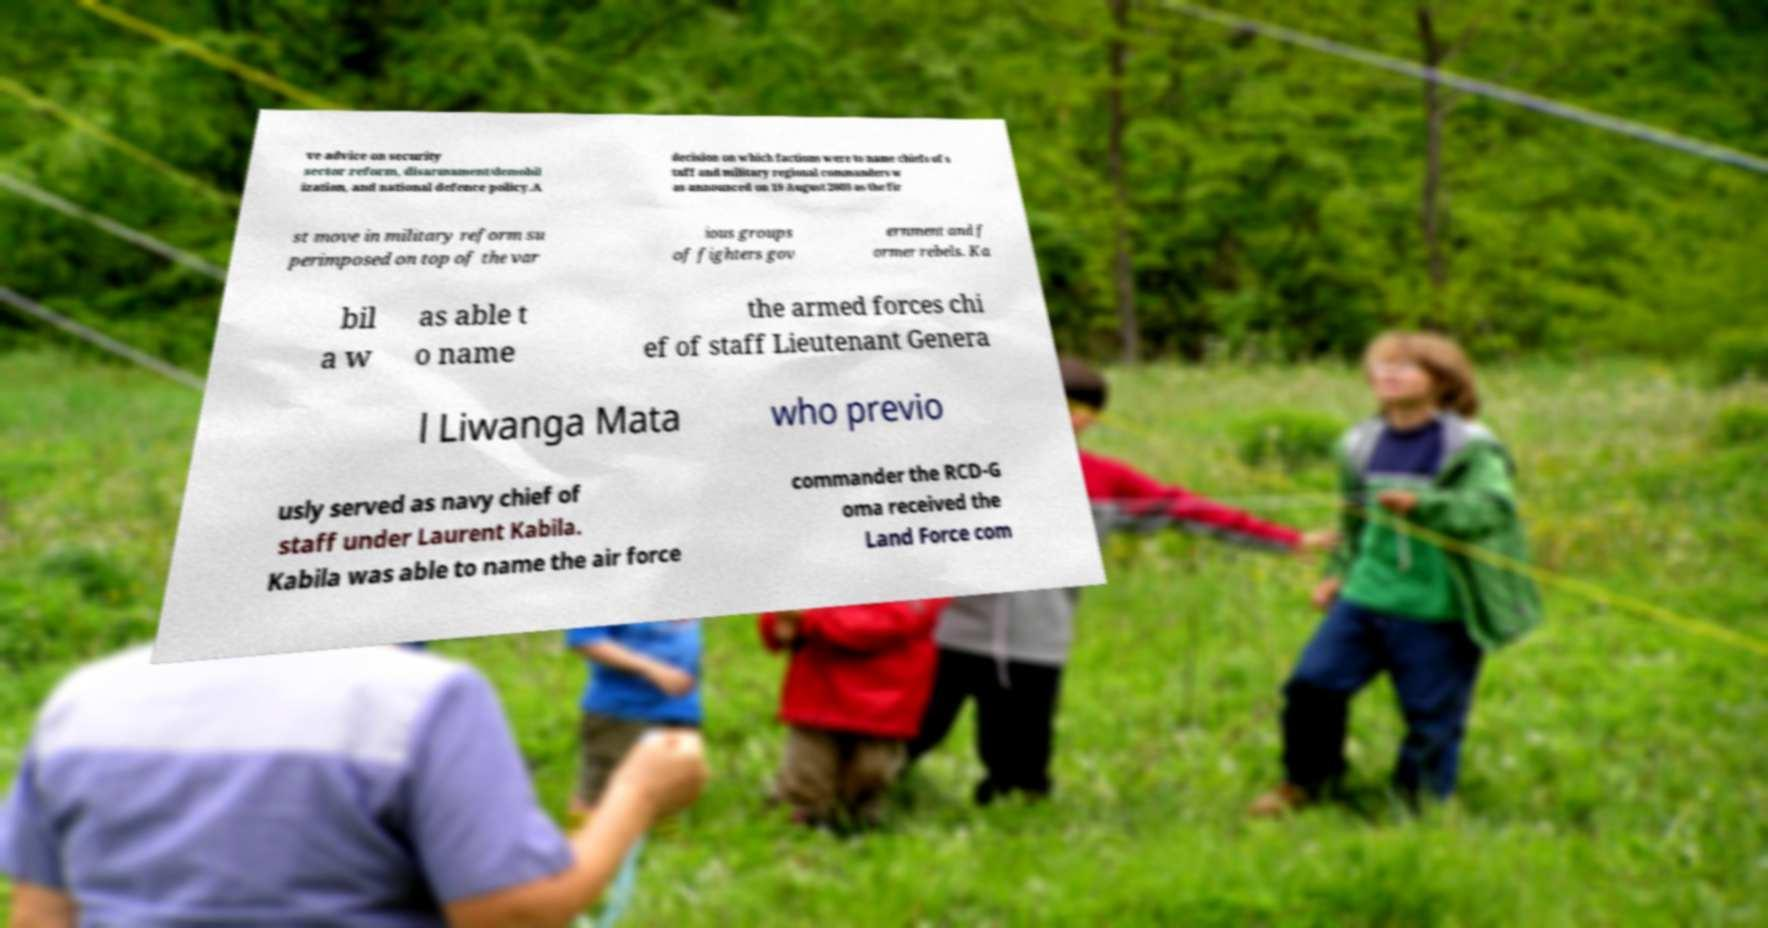Could you extract and type out the text from this image? ve advice on security sector reform, disarmament/demobil ization, and national defence policy.A decision on which factions were to name chiefs of s taff and military regional commanders w as announced on 19 August 2003 as the fir st move in military reform su perimposed on top of the var ious groups of fighters gov ernment and f ormer rebels. Ka bil a w as able t o name the armed forces chi ef of staff Lieutenant Genera l Liwanga Mata who previo usly served as navy chief of staff under Laurent Kabila. Kabila was able to name the air force commander the RCD-G oma received the Land Force com 